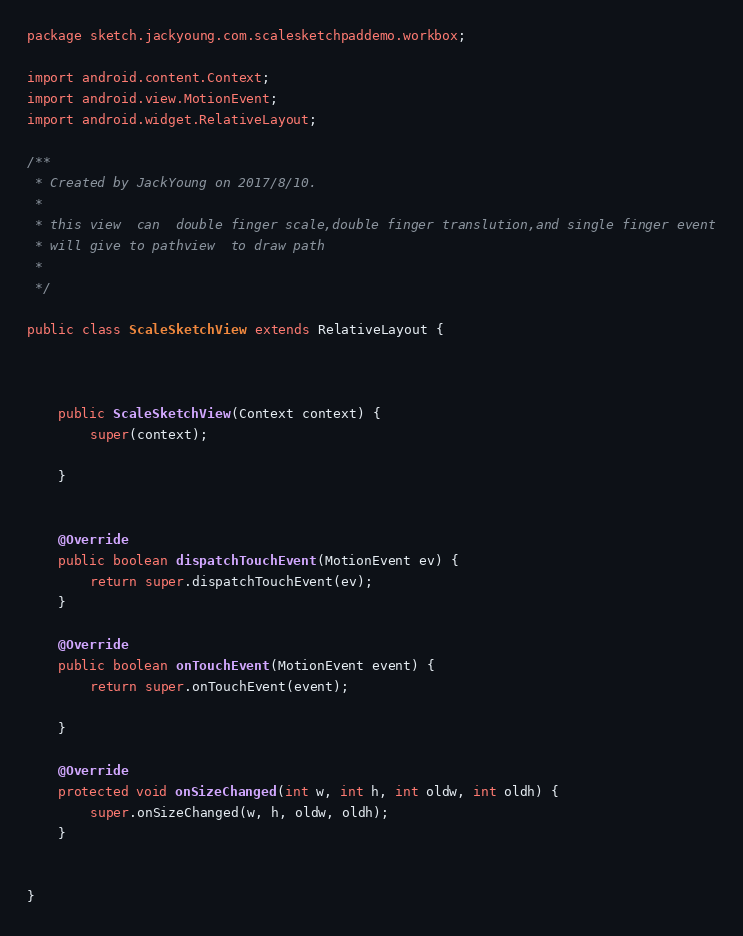Convert code to text. <code><loc_0><loc_0><loc_500><loc_500><_Java_>package sketch.jackyoung.com.scalesketchpaddemo.workbox;

import android.content.Context;
import android.view.MotionEvent;
import android.widget.RelativeLayout;

/**
 * Created by JackYoung on 2017/8/10.
 *
 * this view  can  double finger scale,double finger translution,and single finger event
 * will give to pathview  to draw path
 *
 */

public class ScaleSketchView extends RelativeLayout {



    public ScaleSketchView(Context context) {
        super(context);

    }


    @Override
    public boolean dispatchTouchEvent(MotionEvent ev) {
        return super.dispatchTouchEvent(ev);
    }

    @Override
    public boolean onTouchEvent(MotionEvent event) {
        return super.onTouchEvent(event);

    }

    @Override
    protected void onSizeChanged(int w, int h, int oldw, int oldh) {
        super.onSizeChanged(w, h, oldw, oldh);
    }


}
</code> 